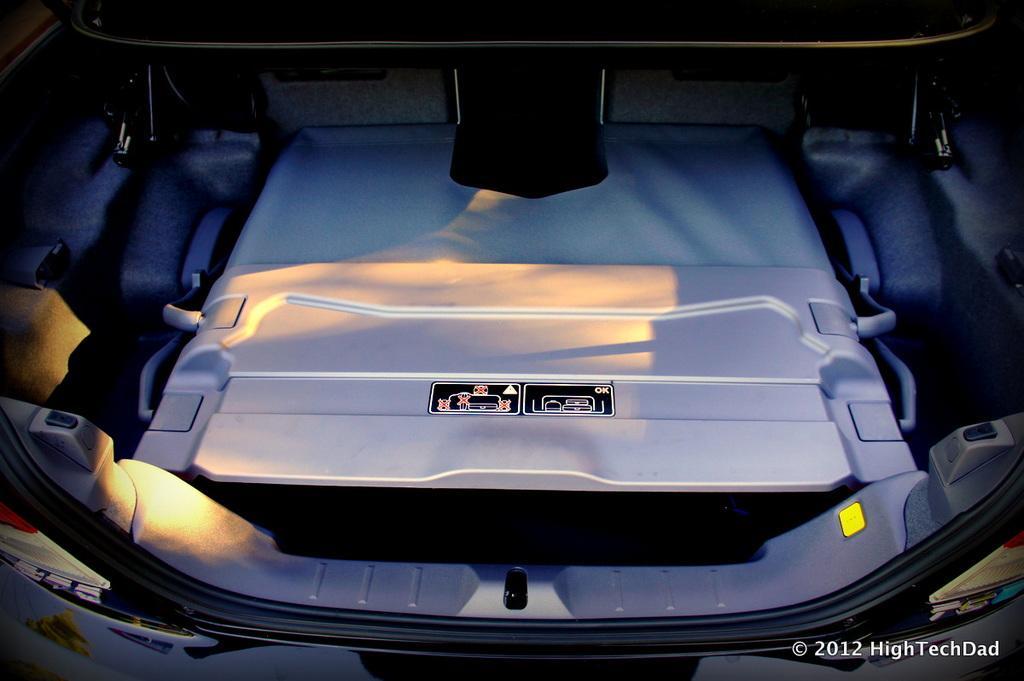In one or two sentences, can you explain what this image depicts? In this picture we can see a trunk of a vehicle, at the right bottom there is some text. 